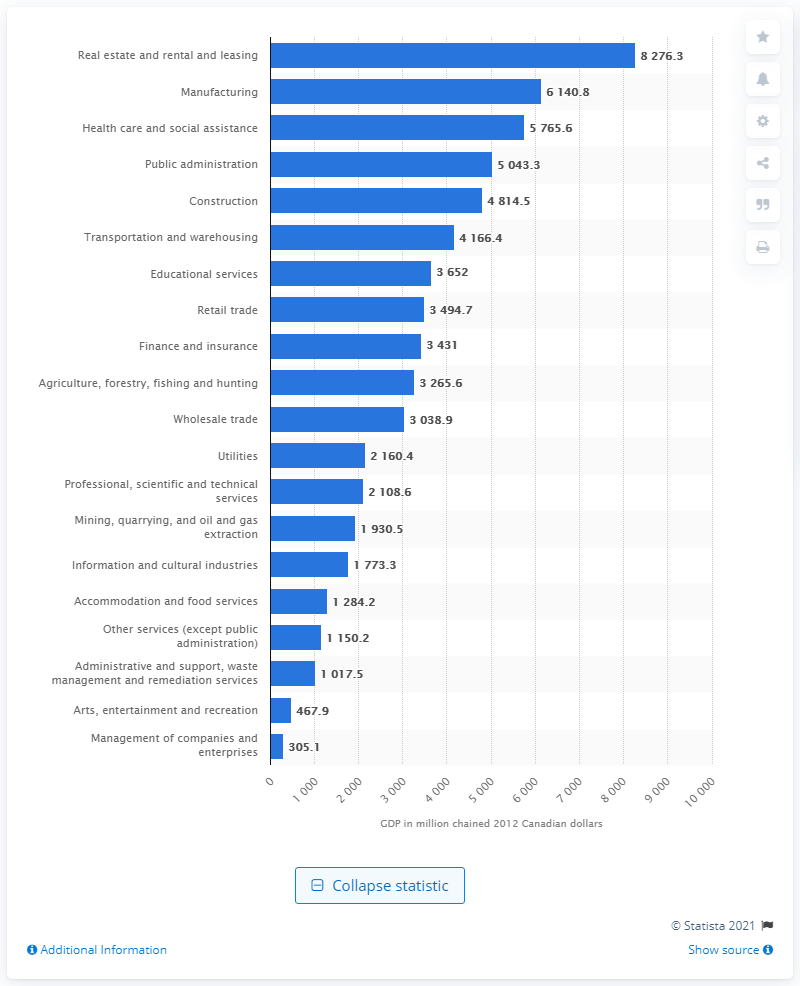Specify some key components in this picture. In 2012, the Gross Domestic Product (GDP) of the construction industry in Manitoba was 4814.5 million Canadian dollars. 